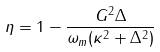<formula> <loc_0><loc_0><loc_500><loc_500>\eta = 1 - \frac { G ^ { 2 } \Delta } { \omega _ { m } ( \kappa ^ { 2 } + \Delta ^ { 2 } ) }</formula> 